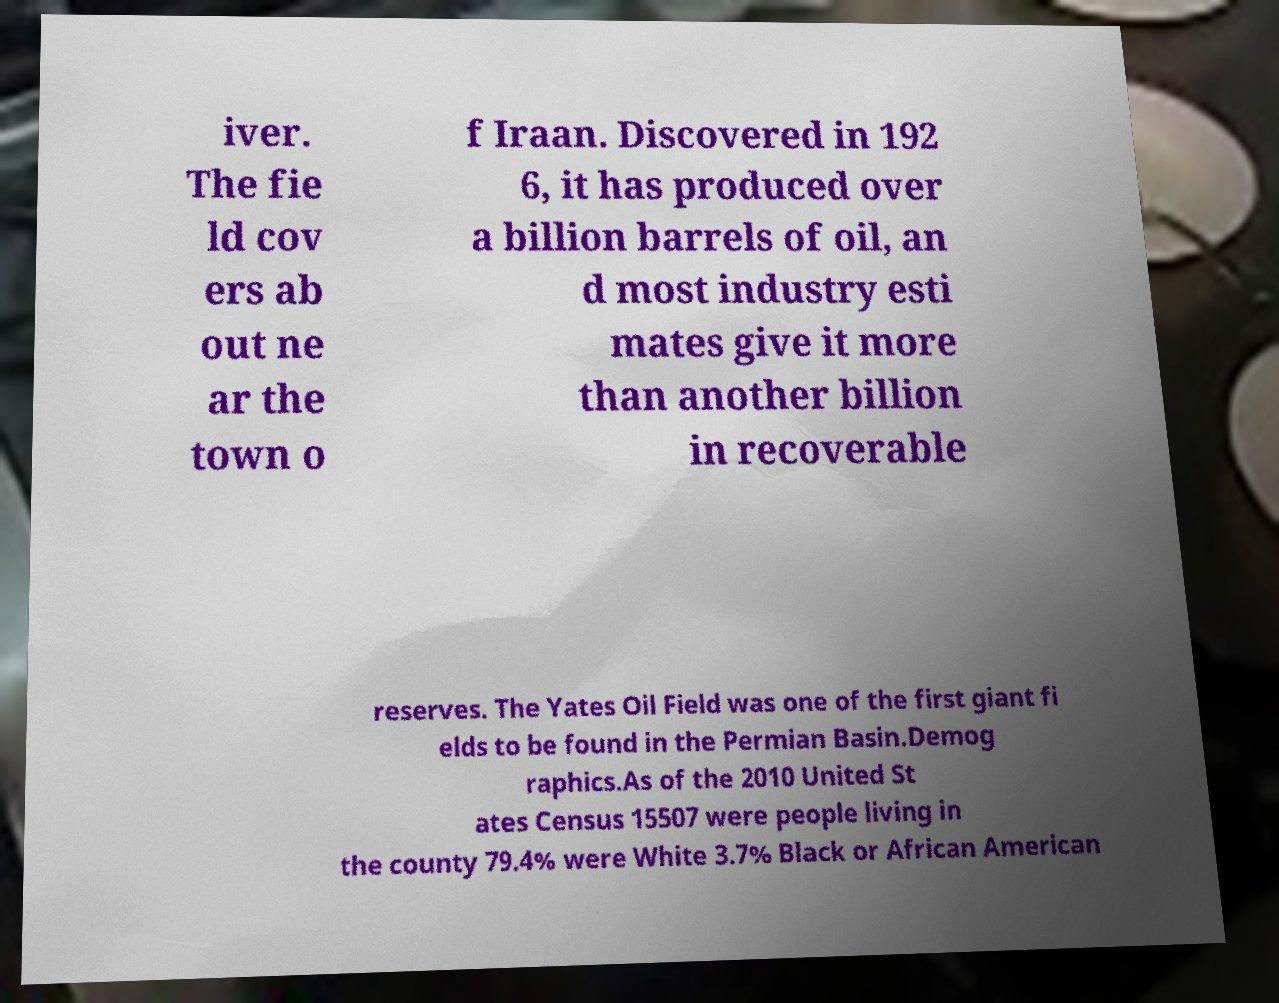Can you read and provide the text displayed in the image?This photo seems to have some interesting text. Can you extract and type it out for me? iver. The fie ld cov ers ab out ne ar the town o f Iraan. Discovered in 192 6, it has produced over a billion barrels of oil, an d most industry esti mates give it more than another billion in recoverable reserves. The Yates Oil Field was one of the first giant fi elds to be found in the Permian Basin.Demog raphics.As of the 2010 United St ates Census 15507 were people living in the county 79.4% were White 3.7% Black or African American 